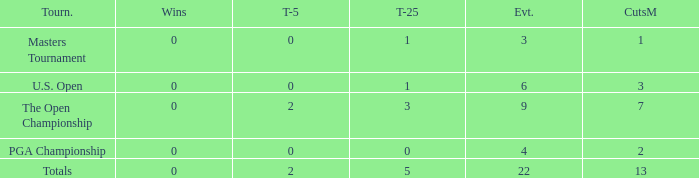What is the average number of cuts made for events with under 4 entries and more than 0 wins? None. 